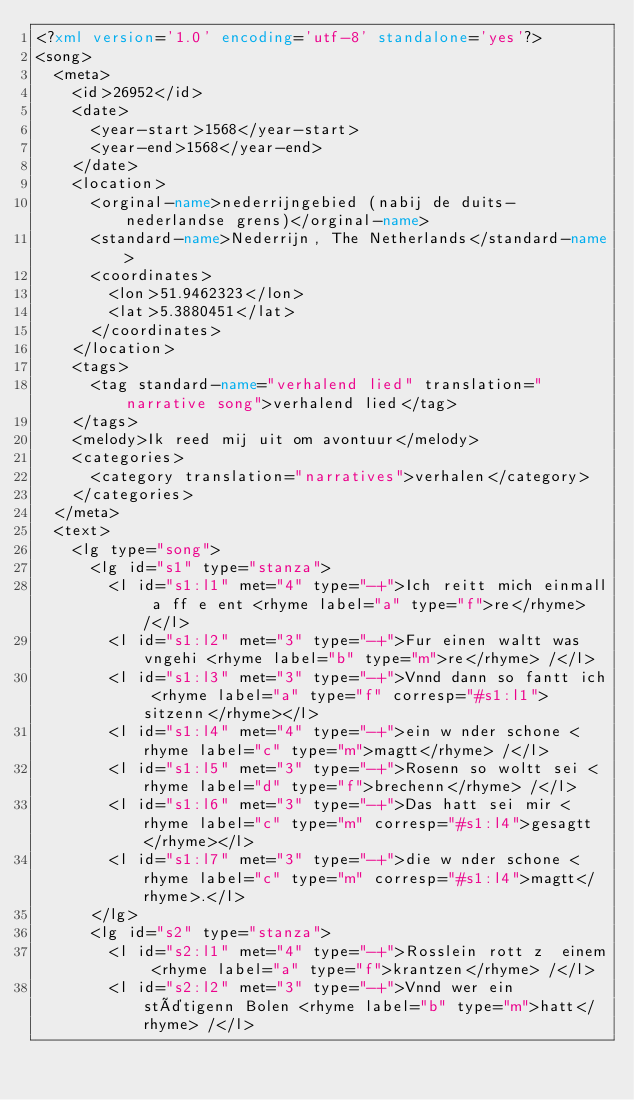Convert code to text. <code><loc_0><loc_0><loc_500><loc_500><_XML_><?xml version='1.0' encoding='utf-8' standalone='yes'?>
<song>
  <meta>
    <id>26952</id>
    <date>
      <year-start>1568</year-start>
      <year-end>1568</year-end>
    </date>
    <location>
      <orginal-name>nederrijngebied (nabij de duits-nederlandse grens)</orginal-name>
      <standard-name>Nederrijn, The Netherlands</standard-name>
      <coordinates>
        <lon>51.9462323</lon>
        <lat>5.3880451</lat>
      </coordinates>
    </location>
    <tags>
      <tag standard-name="verhalend lied" translation="narrative song">verhalend lied</tag>
    </tags>
    <melody>Ik reed mij uit om avontuur</melody>
    <categories>
      <category translation="narratives">verhalen</category>
    </categories>
  </meta>
  <text>
    <lg type="song">
      <lg id="s1" type="stanza">
        <l id="s1:l1" met="4" type="-+">Ich reitt mich einmall a ff e ent <rhyme label="a" type="f">re</rhyme> /</l>
        <l id="s1:l2" met="3" type="-+">Fur einen waltt was vngehi <rhyme label="b" type="m">re</rhyme> /</l>
        <l id="s1:l3" met="3" type="-+">Vnnd dann so fantt ich <rhyme label="a" type="f" corresp="#s1:l1">sitzenn</rhyme></l>
        <l id="s1:l4" met="4" type="-+">ein w nder schone <rhyme label="c" type="m">magtt</rhyme> /</l>
        <l id="s1:l5" met="3" type="-+">Rosenn so woltt sei <rhyme label="d" type="f">brechenn</rhyme> /</l>
        <l id="s1:l6" met="3" type="-+">Das hatt sei mir <rhyme label="c" type="m" corresp="#s1:l4">gesagtt</rhyme></l>
        <l id="s1:l7" met="3" type="-+">die w nder schone <rhyme label="c" type="m" corresp="#s1:l4">magtt</rhyme>.</l>
      </lg>
      <lg id="s2" type="stanza">
        <l id="s2:l1" met="4" type="-+">Rosslein rott z  einem <rhyme label="a" type="f">krantzen</rhyme> /</l>
        <l id="s2:l2" met="3" type="-+">Vnnd wer ein stätigenn Bolen <rhyme label="b" type="m">hatt</rhyme> /</l></code> 